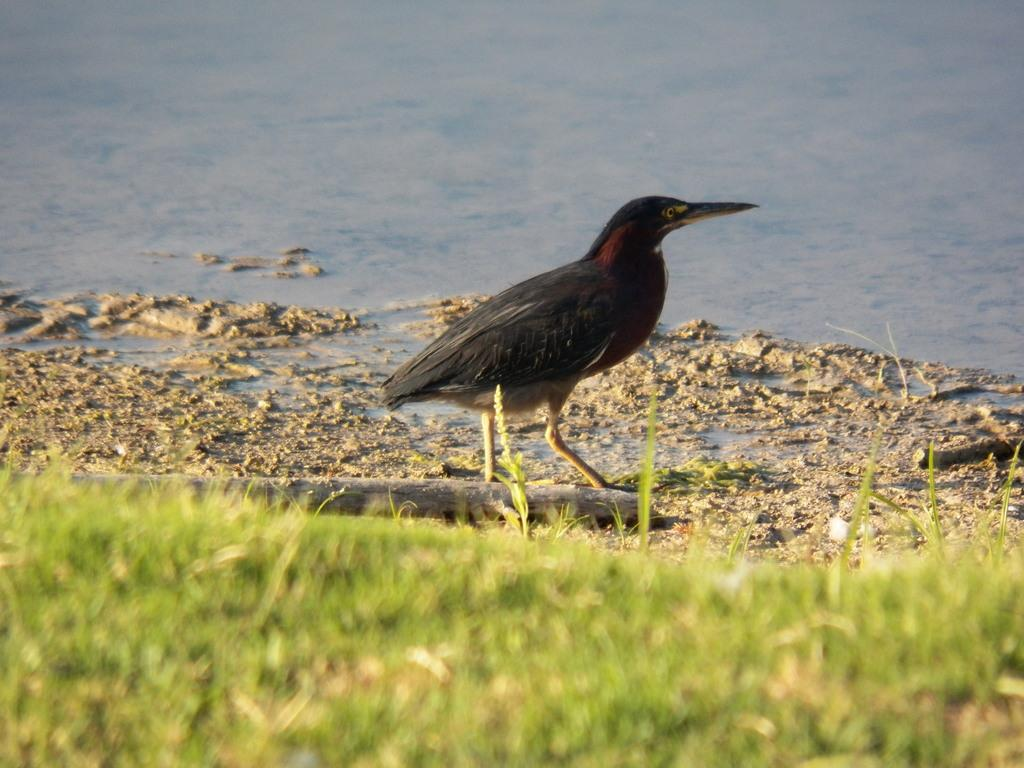What type of vegetation is in the foreground of the image? There is grass in the foreground of the image. What animal can be seen in the middle of the image? There is a bird in the middle of the image. What substance is present in the middle of the image? There is mud in the middle of the image. What natural feature is visible at the top of the image? There is a water body visible at the top of the image. Reasoning: Let' Let's think step by step in order to produce the conversation. We start by identifying the main subjects and objects in the image based on the provided facts. We then formulate questions that focus on the location and characteristics of these subjects and objects, ensuring that each question can be answered definitively with the information given. We avoid yes/no questions and ensure that the language is simple and clear. Absurd Question/Answer: What type of grain is being harvested by the plane in the image? There is no plane present in the image, and therefore no grain harvesting can be observed. What health benefits can be gained from the bird in the image? The image does not provide information about the health benefits of the bird; it simply shows a bird in the middle of the image. 